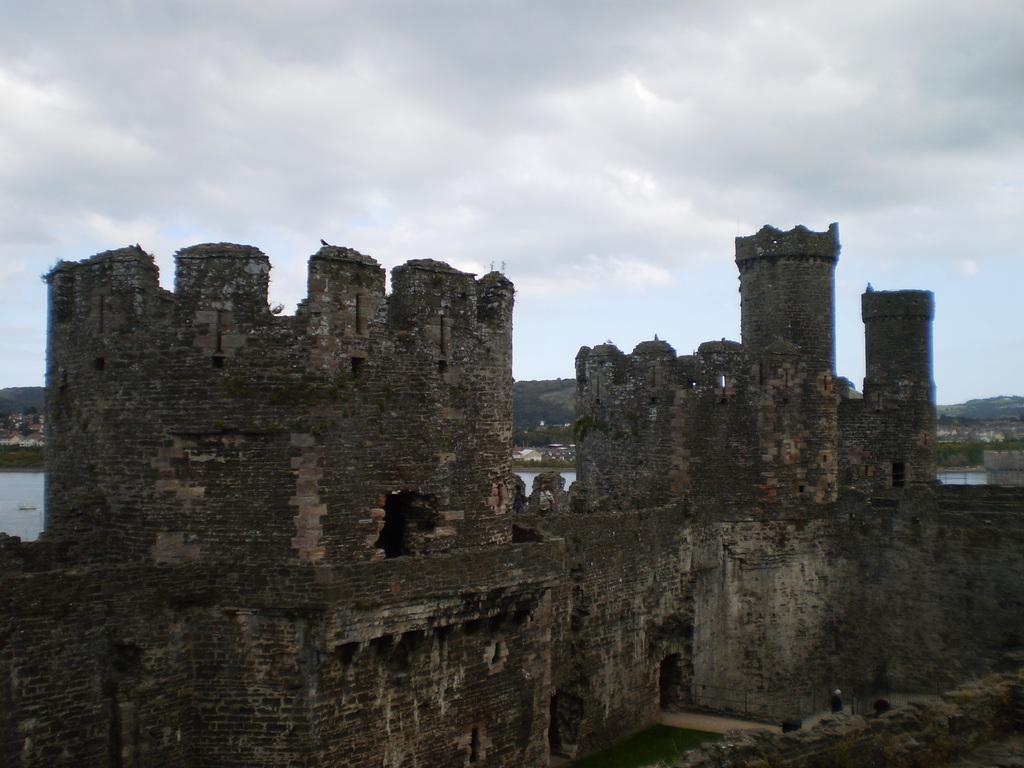Could you give a brief overview of what you see in this image? In the center of the image there is a old fort. In the background of the image there are mountains. There is water. 